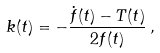<formula> <loc_0><loc_0><loc_500><loc_500>k ( t ) = - \frac { \dot { f } ( t ) - T ( t ) } { 2 f ( t ) } \, ,</formula> 